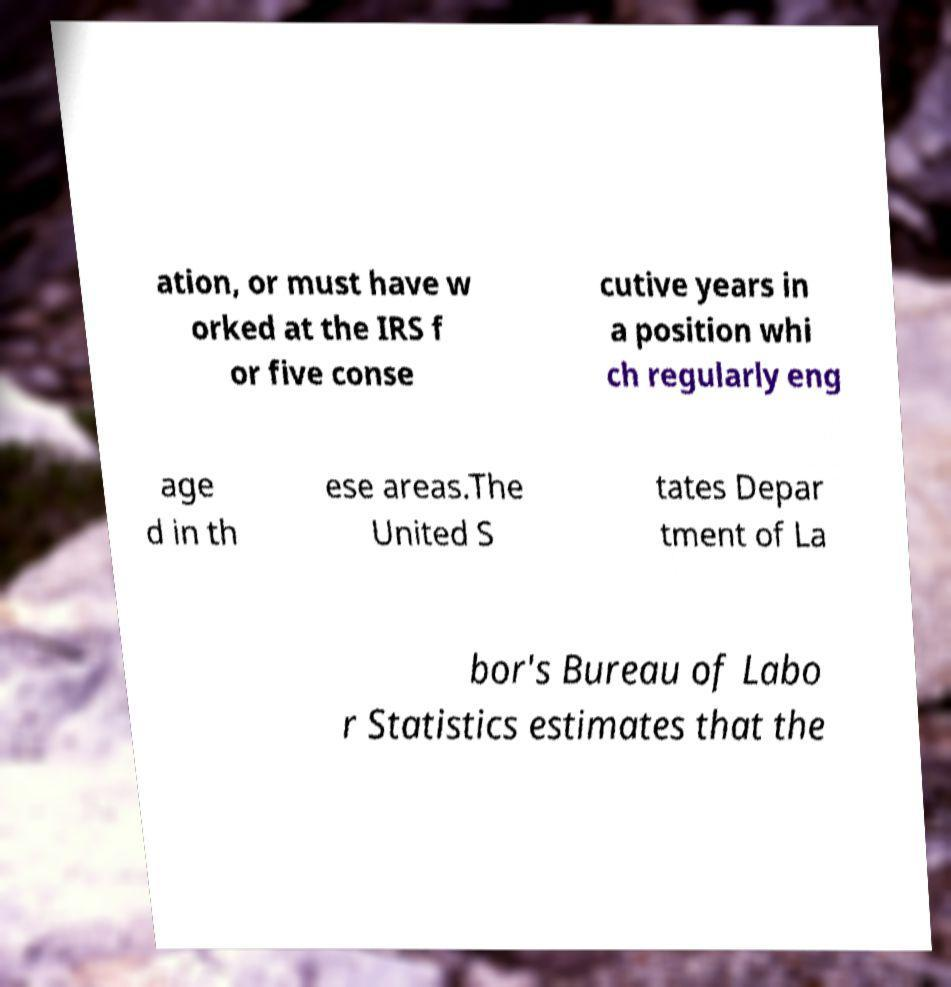Could you assist in decoding the text presented in this image and type it out clearly? ation, or must have w orked at the IRS f or five conse cutive years in a position whi ch regularly eng age d in th ese areas.The United S tates Depar tment of La bor's Bureau of Labo r Statistics estimates that the 